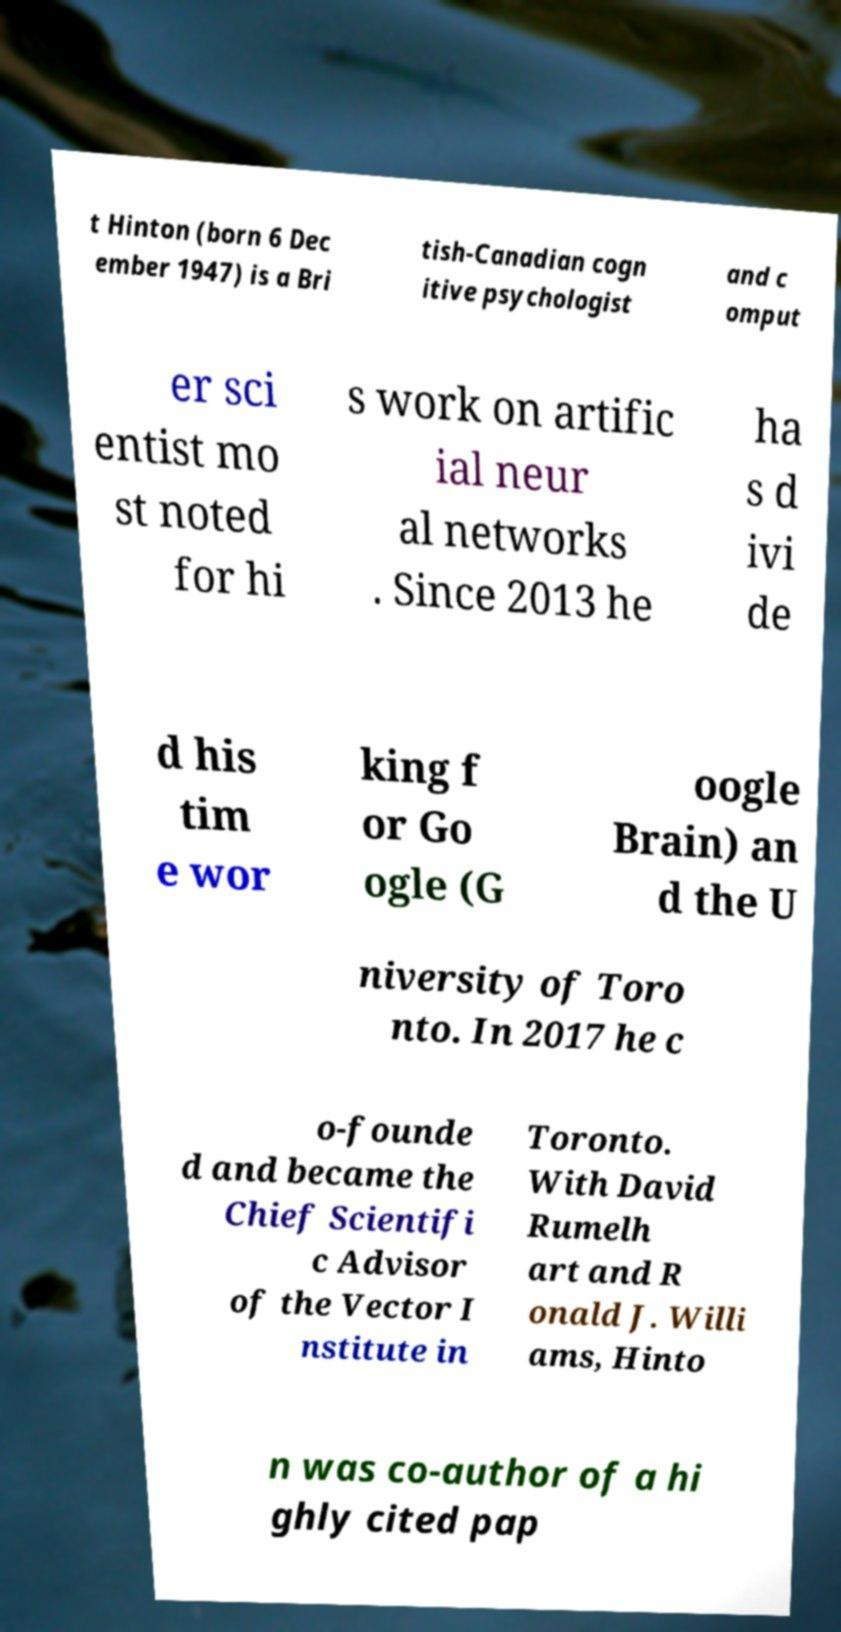For documentation purposes, I need the text within this image transcribed. Could you provide that? t Hinton (born 6 Dec ember 1947) is a Bri tish-Canadian cogn itive psychologist and c omput er sci entist mo st noted for hi s work on artific ial neur al networks . Since 2013 he ha s d ivi de d his tim e wor king f or Go ogle (G oogle Brain) an d the U niversity of Toro nto. In 2017 he c o-founde d and became the Chief Scientifi c Advisor of the Vector I nstitute in Toronto. With David Rumelh art and R onald J. Willi ams, Hinto n was co-author of a hi ghly cited pap 